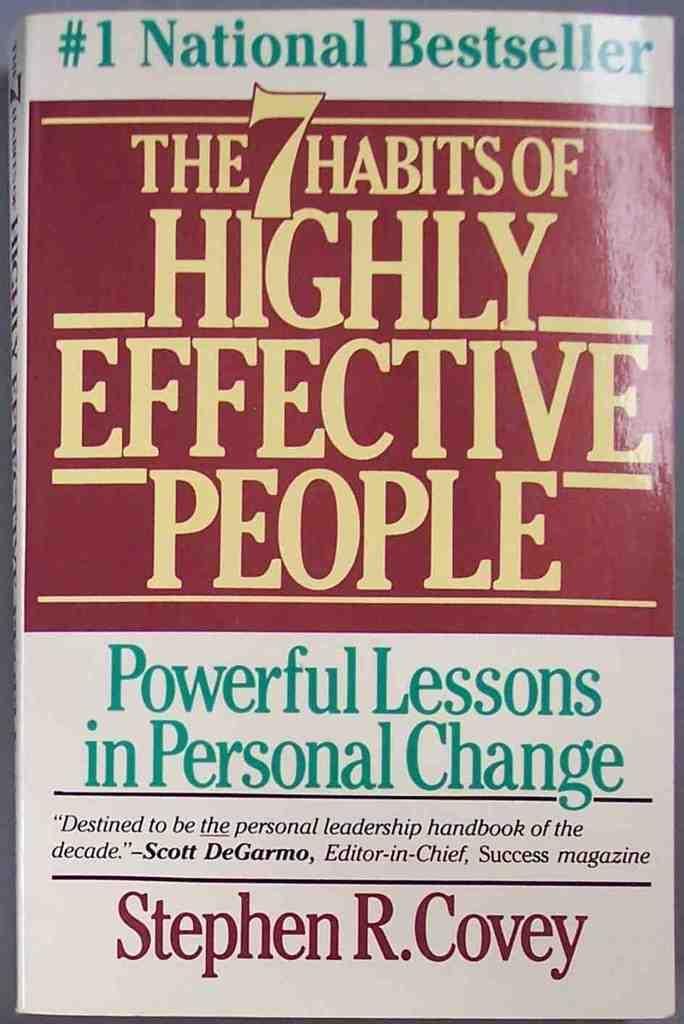<image>
Give a short and clear explanation of the subsequent image. a #1 national bestseller book the 7 habits of highly effective people 